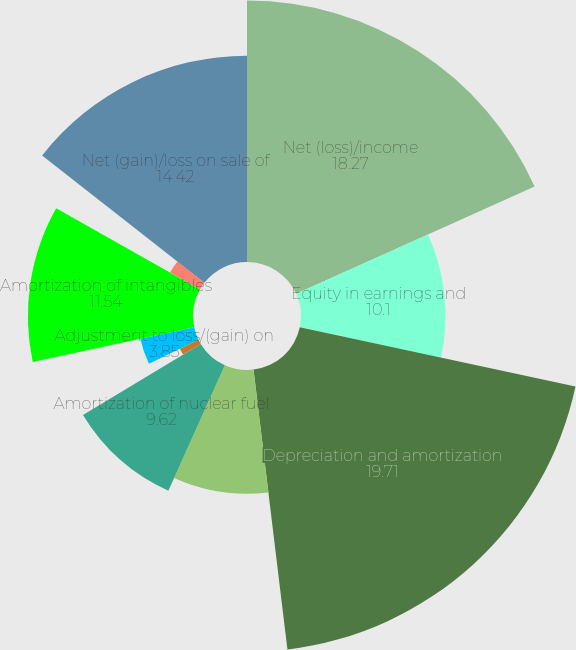<chart> <loc_0><loc_0><loc_500><loc_500><pie_chart><fcel>Net (loss)/income<fcel>Equity in earnings and<fcel>Depreciation and amortization<fcel>Provision for bad debts<fcel>Amortization of nuclear fuel<fcel>Amortization of financing<fcel>Adjustment to loss/(gain) on<fcel>Amortization of intangibles<fcel>Amortization of unearned<fcel>Net (gain)/loss on sale of<nl><fcel>18.27%<fcel>10.1%<fcel>19.71%<fcel>8.65%<fcel>9.62%<fcel>1.44%<fcel>3.85%<fcel>11.54%<fcel>2.4%<fcel>14.42%<nl></chart> 